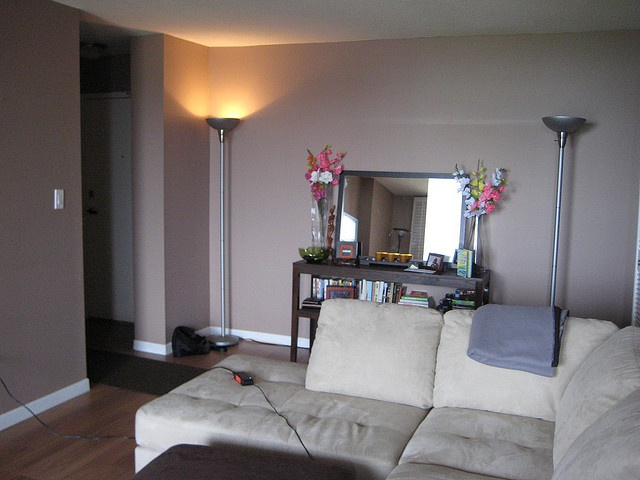Describe the objects in this image and their specific colors. I can see couch in black, darkgray, lightgray, and gray tones, vase in black, darkgray, gray, and darkgreen tones, vase in black, gray, and white tones, book in black, gray, and darkgray tones, and bowl in black, gray, darkgreen, and darkgray tones in this image. 